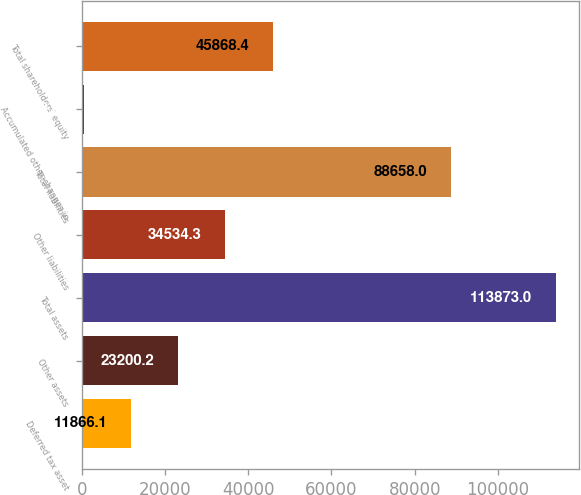Convert chart. <chart><loc_0><loc_0><loc_500><loc_500><bar_chart><fcel>Deferred tax asset<fcel>Other assets<fcel>Total assets<fcel>Other liabilities<fcel>Total liabilities<fcel>Accumulated other changes in<fcel>Total shareholders' equity<nl><fcel>11866.1<fcel>23200.2<fcel>113873<fcel>34534.3<fcel>88658<fcel>532<fcel>45868.4<nl></chart> 